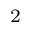Convert formula to latex. <formula><loc_0><loc_0><loc_500><loc_500>^ { 2 }</formula> 